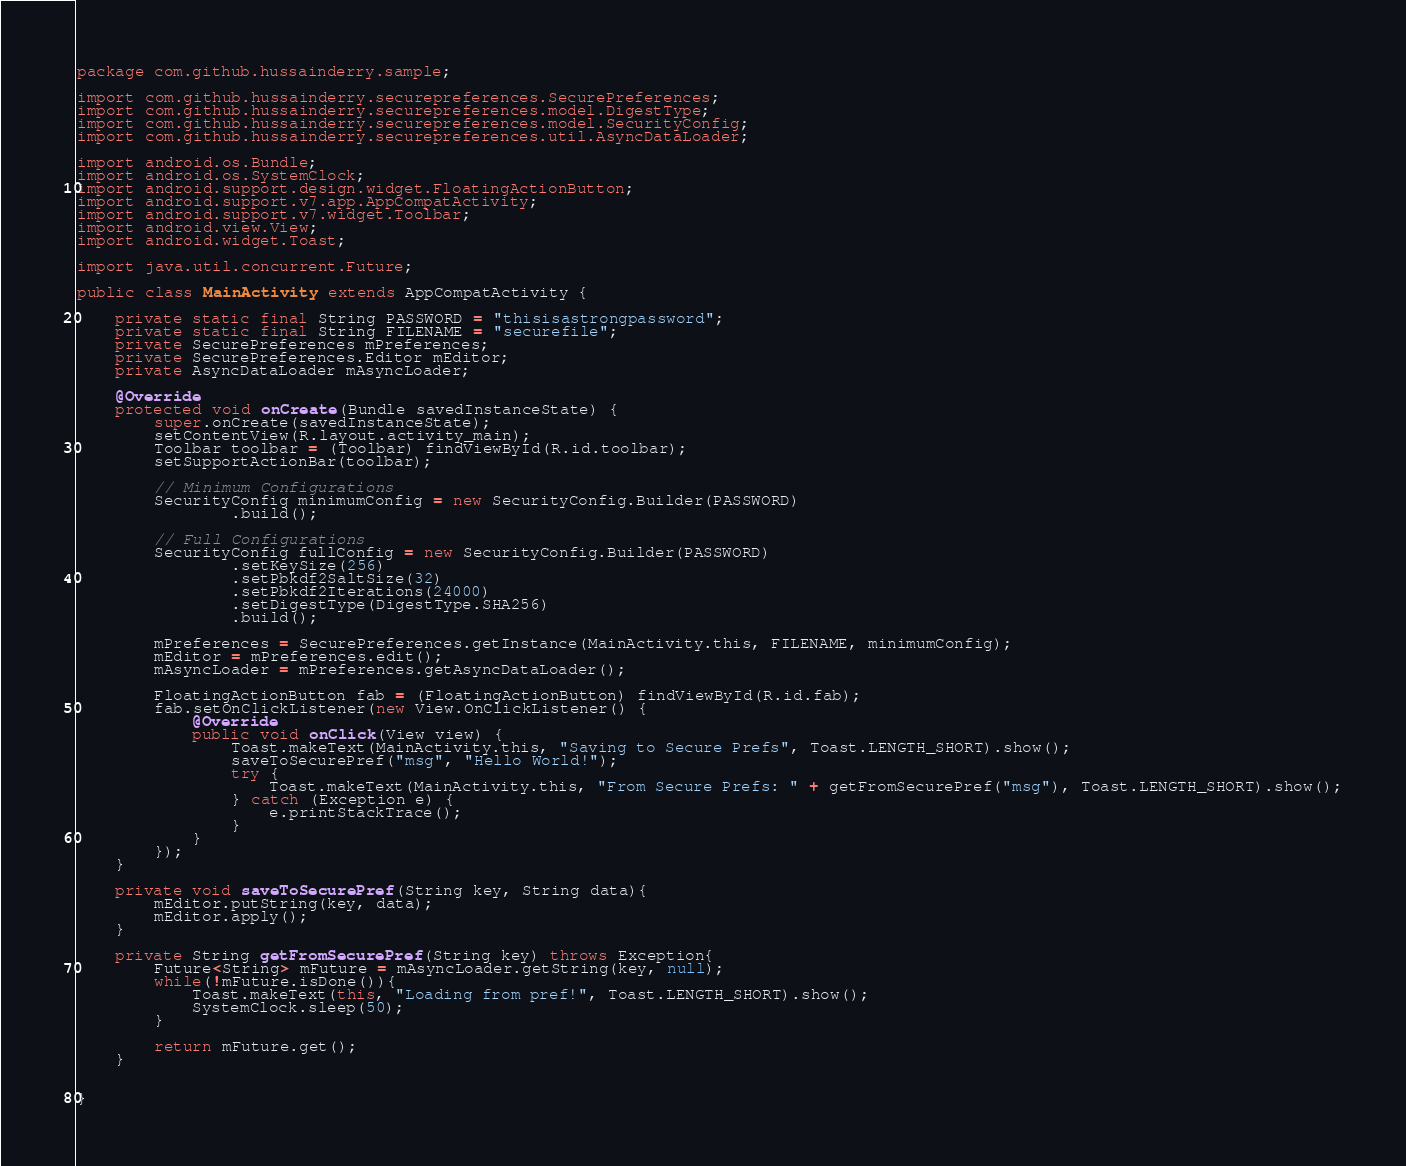Convert code to text. <code><loc_0><loc_0><loc_500><loc_500><_Java_>package com.github.hussainderry.sample;

import com.github.hussainderry.securepreferences.SecurePreferences;
import com.github.hussainderry.securepreferences.model.DigestType;
import com.github.hussainderry.securepreferences.model.SecurityConfig;
import com.github.hussainderry.securepreferences.util.AsyncDataLoader;

import android.os.Bundle;
import android.os.SystemClock;
import android.support.design.widget.FloatingActionButton;
import android.support.v7.app.AppCompatActivity;
import android.support.v7.widget.Toolbar;
import android.view.View;
import android.widget.Toast;

import java.util.concurrent.Future;

public class MainActivity extends AppCompatActivity {

    private static final String PASSWORD = "thisisastrongpassword";
    private static final String FILENAME = "securefile";
    private SecurePreferences mPreferences;
    private SecurePreferences.Editor mEditor;
    private AsyncDataLoader mAsyncLoader;

    @Override
    protected void onCreate(Bundle savedInstanceState) {
        super.onCreate(savedInstanceState);
        setContentView(R.layout.activity_main);
        Toolbar toolbar = (Toolbar) findViewById(R.id.toolbar);
        setSupportActionBar(toolbar);

        // Minimum Configurations
        SecurityConfig minimumConfig = new SecurityConfig.Builder(PASSWORD)
                .build();

        // Full Configurations
        SecurityConfig fullConfig = new SecurityConfig.Builder(PASSWORD)
                .setKeySize(256)
                .setPbkdf2SaltSize(32)
                .setPbkdf2Iterations(24000)
                .setDigestType(DigestType.SHA256)
                .build();

        mPreferences = SecurePreferences.getInstance(MainActivity.this, FILENAME, minimumConfig);
        mEditor = mPreferences.edit();
        mAsyncLoader = mPreferences.getAsyncDataLoader();

        FloatingActionButton fab = (FloatingActionButton) findViewById(R.id.fab);
        fab.setOnClickListener(new View.OnClickListener() {
            @Override
            public void onClick(View view) {
                Toast.makeText(MainActivity.this, "Saving to Secure Prefs", Toast.LENGTH_SHORT).show();
                saveToSecurePref("msg", "Hello World!");
                try {
                    Toast.makeText(MainActivity.this, "From Secure Prefs: " + getFromSecurePref("msg"), Toast.LENGTH_SHORT).show();
                } catch (Exception e) {
                    e.printStackTrace();
                }
            }
        });
    }

    private void saveToSecurePref(String key, String data){
        mEditor.putString(key, data);
        mEditor.apply();
    }

    private String getFromSecurePref(String key) throws Exception{
        Future<String> mFuture = mAsyncLoader.getString(key, null);
        while(!mFuture.isDone()){
            Toast.makeText(this, "Loading from pref!", Toast.LENGTH_SHORT).show();
            SystemClock.sleep(50);
        }

        return mFuture.get();
    }


}
</code> 